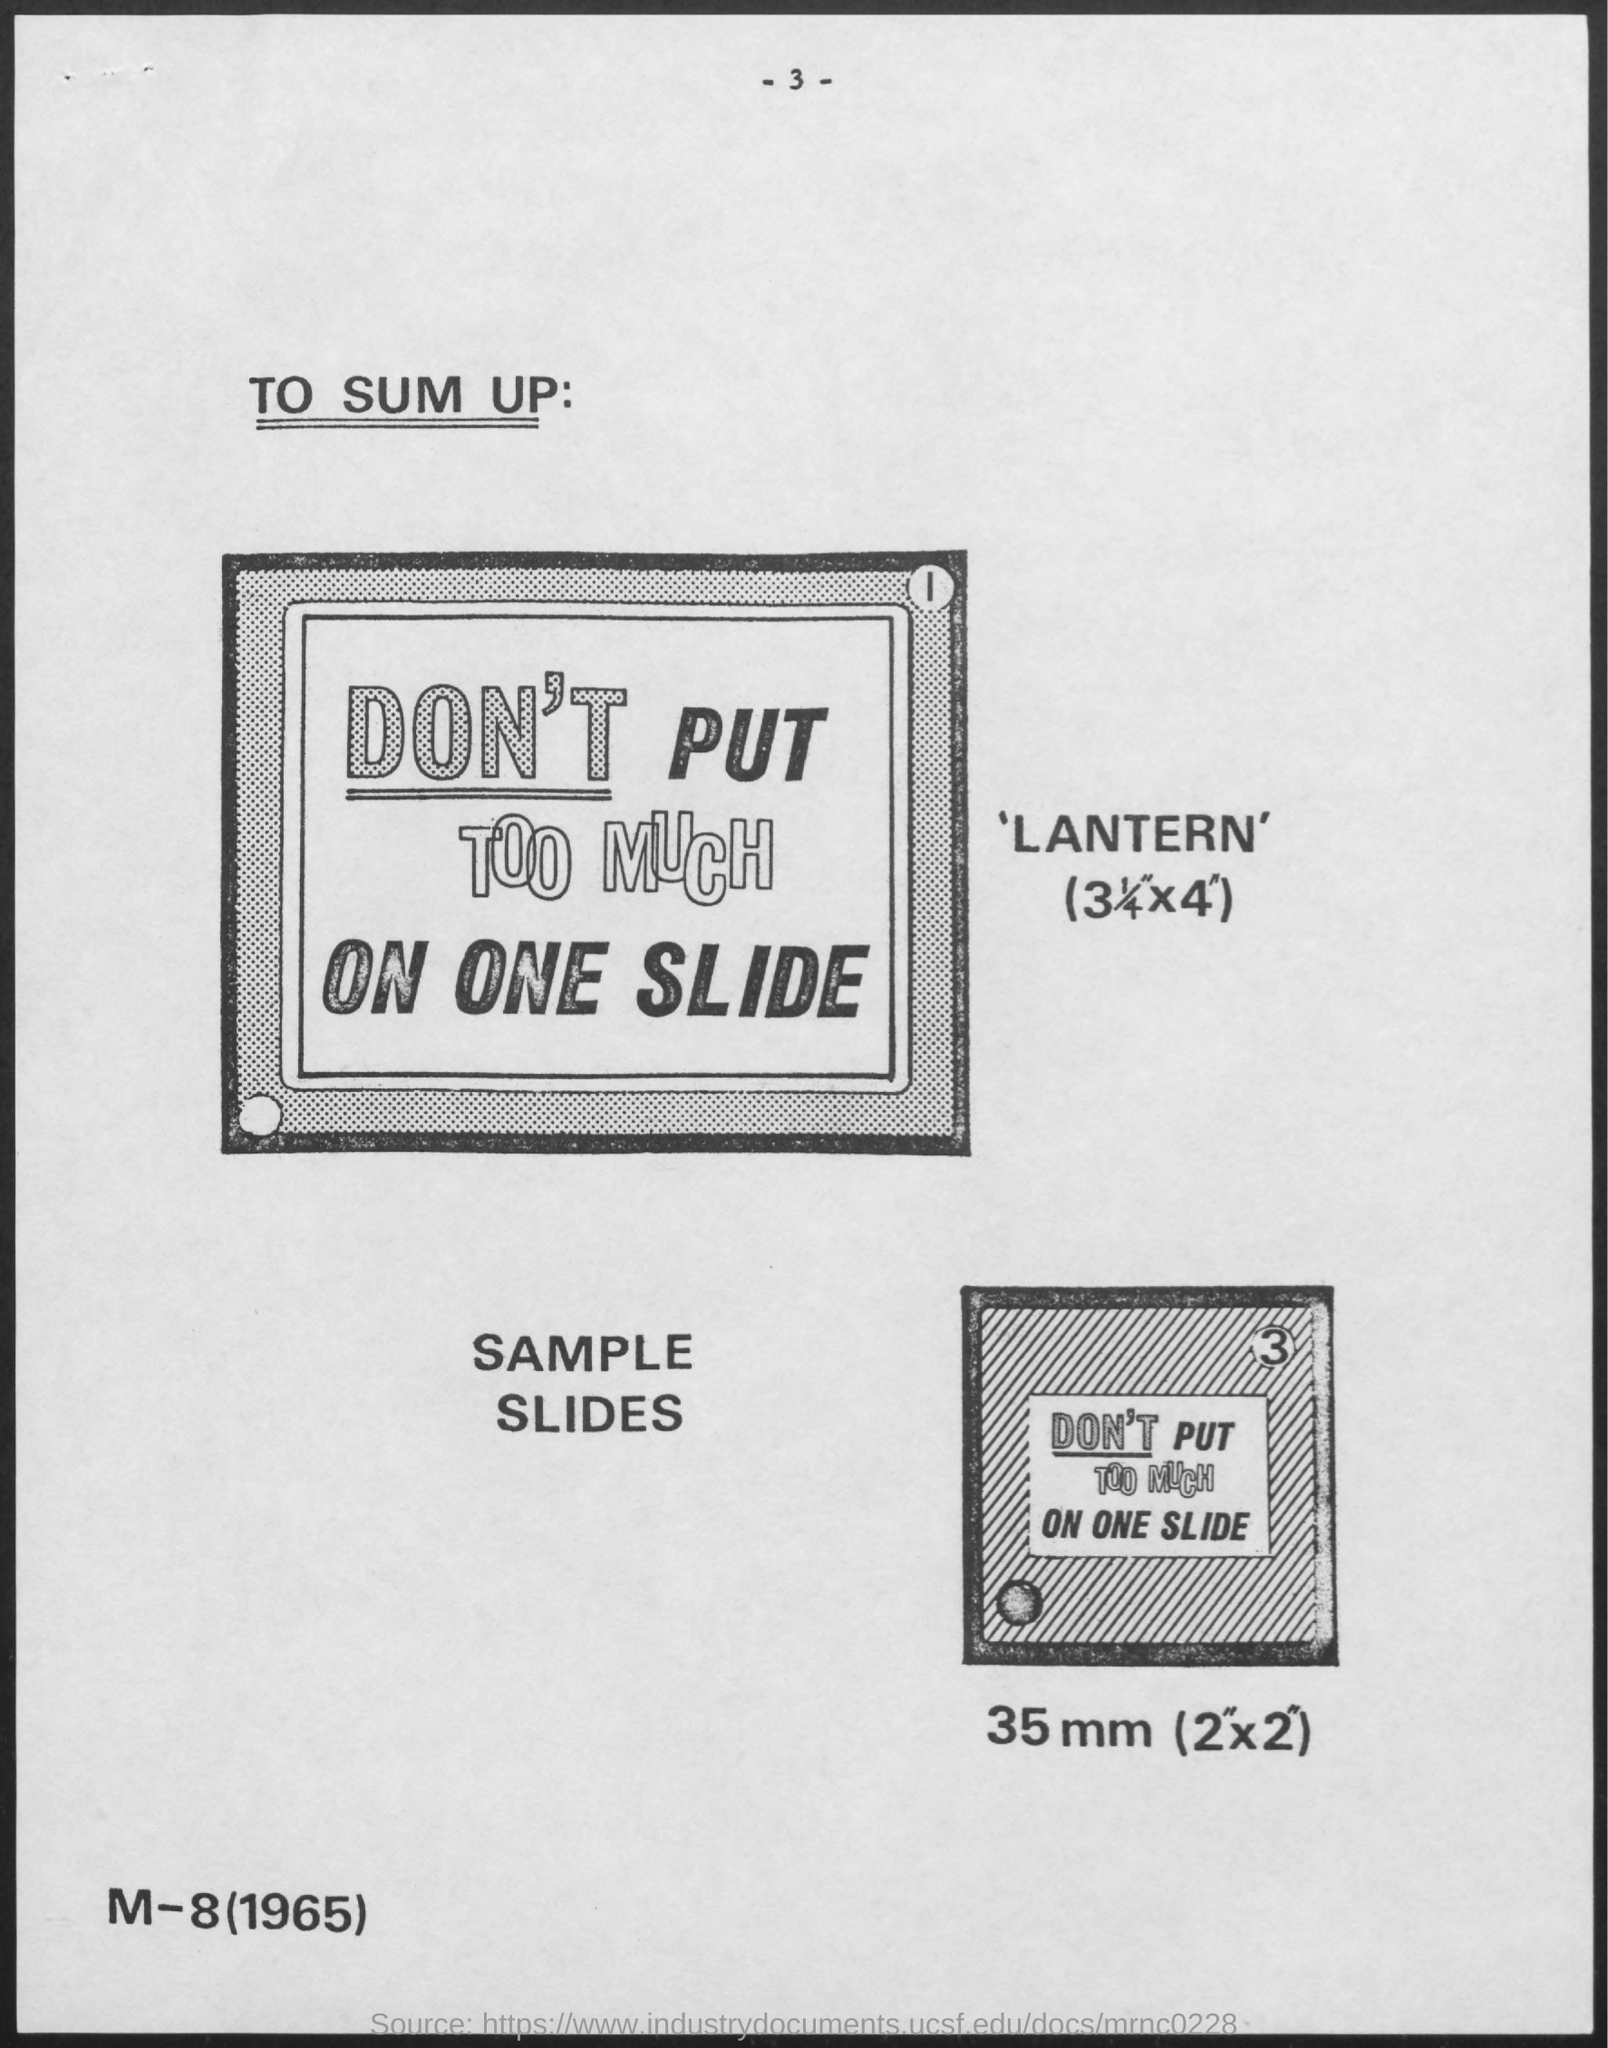What is the Page Number?
Your response must be concise. - 3 -. What is the first title in the document?
Give a very brief answer. To Sum Up:. What is the length of one side of the the second (bottom one) box?
Give a very brief answer. 35 mm (2"x2"). 